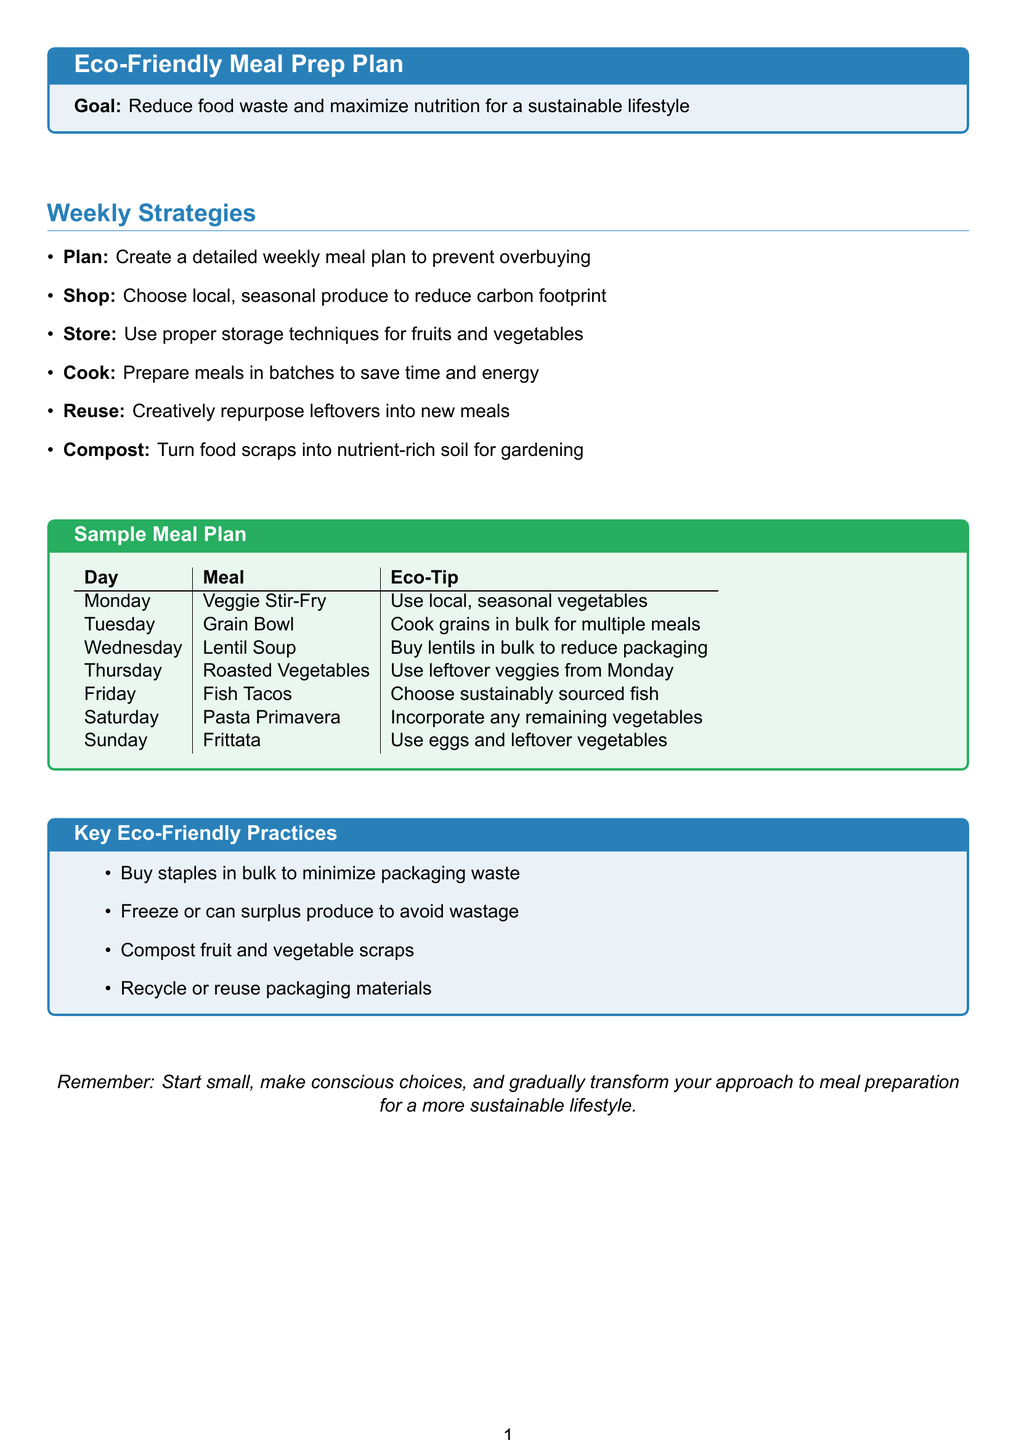What is the main goal of the meal prep plan? The main goal is to reduce food waste and maximize nutrition for a sustainable lifestyle.
Answer: Reduce food waste and maximize nutrition for a sustainable lifestyle What meal is suggested for Tuesday? The meal suggested for Tuesday is listed in the sample meal plan.
Answer: Grain Bowl Which vegetable is used for Monday's dish? The dish for Monday consists of local, seasonal vegetables.
Answer: Local, seasonal vegetables What eco-tip is associated with Wednesday's meal? The eco-tip for Wednesday relates to purchasing lentils.
Answer: Buy lentils in bulk to reduce packaging How many meals are planned for the week? The sample meal plan provides suggestions for each day of the week, totaling seven meals.
Answer: Seven meals What is one key eco-friendly practice mentioned in the document? This practice is detailed in the section labeled "Key Eco-Friendly Practices."
Answer: Buy staples in bulk to minimize packaging waste Which day features fish in the meal plan? The specific day that includes fish tacos can be found in the sample meal plan.
Answer: Friday What can you do with surplus produce according to the document? The document suggests freezing or canning surplus produce to avoid wastage.
Answer: Freeze or can surplus produce What activity is recommended for food scraps? The plan includes a suggestion for handling food scraps in an eco-friendly way.
Answer: Compost fruit and vegetable scraps 